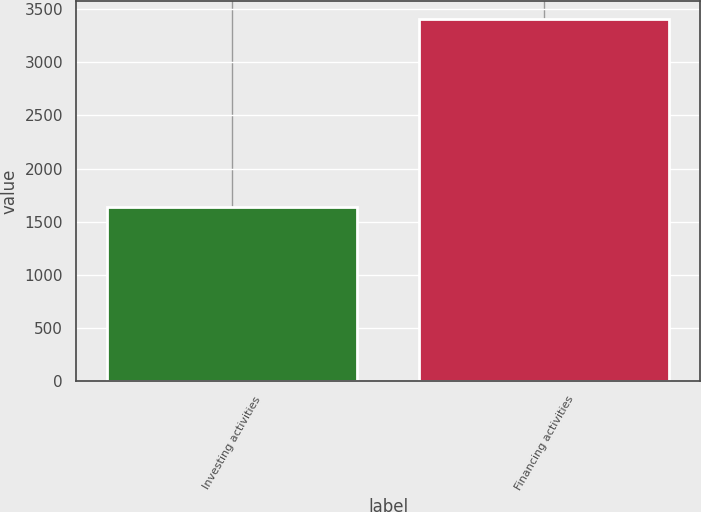Convert chart to OTSL. <chart><loc_0><loc_0><loc_500><loc_500><bar_chart><fcel>Investing activities<fcel>Financing activities<nl><fcel>1636<fcel>3408<nl></chart> 